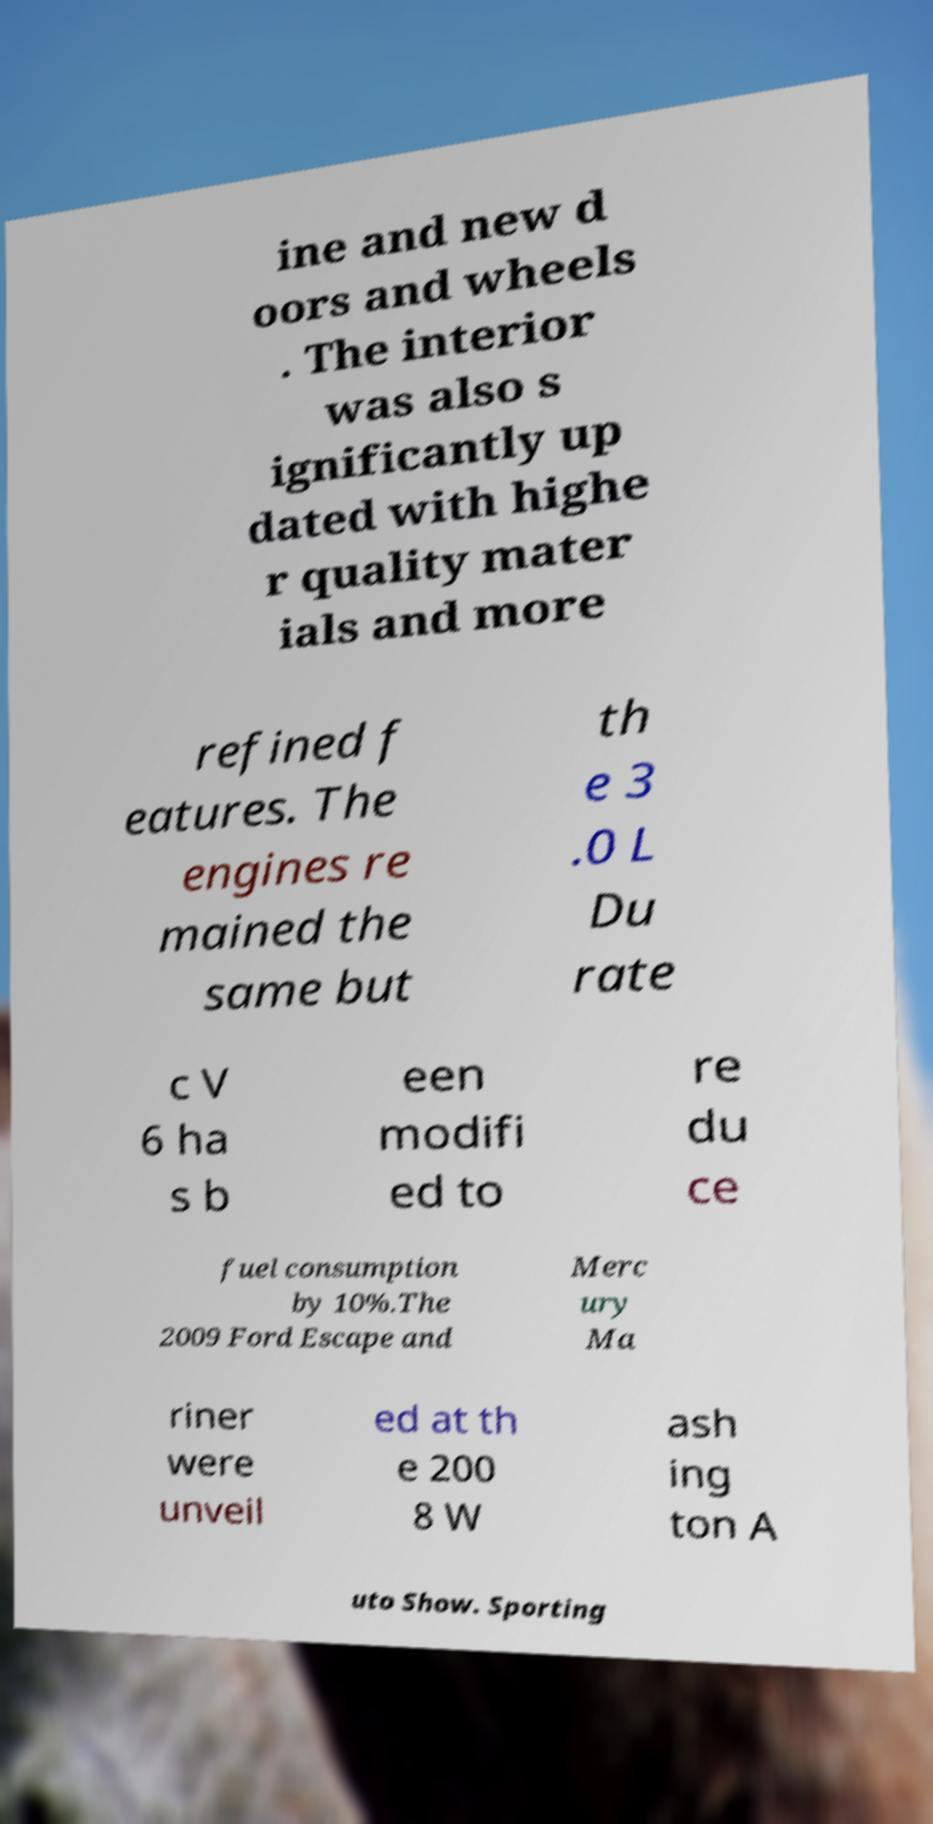Can you read and provide the text displayed in the image?This photo seems to have some interesting text. Can you extract and type it out for me? ine and new d oors and wheels . The interior was also s ignificantly up dated with highe r quality mater ials and more refined f eatures. The engines re mained the same but th e 3 .0 L Du rate c V 6 ha s b een modifi ed to re du ce fuel consumption by 10%.The 2009 Ford Escape and Merc ury Ma riner were unveil ed at th e 200 8 W ash ing ton A uto Show. Sporting 